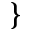<formula> <loc_0><loc_0><loc_500><loc_500>\}</formula> 